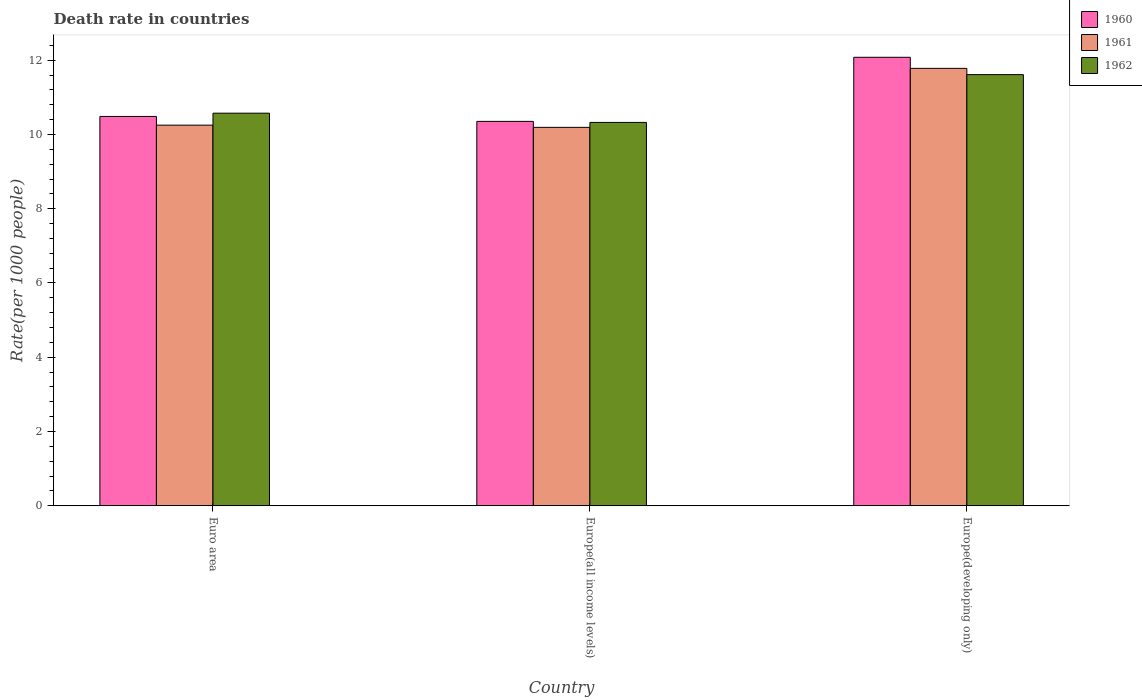How many different coloured bars are there?
Ensure brevity in your answer.  3. How many groups of bars are there?
Make the answer very short. 3. Are the number of bars per tick equal to the number of legend labels?
Your answer should be very brief. Yes. Are the number of bars on each tick of the X-axis equal?
Provide a short and direct response. Yes. How many bars are there on the 3rd tick from the left?
Keep it short and to the point. 3. What is the label of the 2nd group of bars from the left?
Ensure brevity in your answer.  Europe(all income levels). In how many cases, is the number of bars for a given country not equal to the number of legend labels?
Give a very brief answer. 0. What is the death rate in 1962 in Euro area?
Give a very brief answer. 10.57. Across all countries, what is the maximum death rate in 1960?
Ensure brevity in your answer.  12.08. Across all countries, what is the minimum death rate in 1960?
Give a very brief answer. 10.35. In which country was the death rate in 1962 maximum?
Give a very brief answer. Europe(developing only). In which country was the death rate in 1960 minimum?
Make the answer very short. Europe(all income levels). What is the total death rate in 1962 in the graph?
Keep it short and to the point. 32.51. What is the difference between the death rate in 1960 in Euro area and that in Europe(all income levels)?
Offer a very short reply. 0.13. What is the difference between the death rate in 1961 in Euro area and the death rate in 1960 in Europe(developing only)?
Your response must be concise. -1.83. What is the average death rate in 1960 per country?
Keep it short and to the point. 10.97. What is the difference between the death rate of/in 1962 and death rate of/in 1961 in Euro area?
Offer a very short reply. 0.32. In how many countries, is the death rate in 1961 greater than 0.8?
Offer a terse response. 3. What is the ratio of the death rate in 1962 in Euro area to that in Europe(all income levels)?
Give a very brief answer. 1.02. What is the difference between the highest and the second highest death rate in 1962?
Ensure brevity in your answer.  -0.25. What is the difference between the highest and the lowest death rate in 1960?
Provide a succinct answer. 1.73. Is it the case that in every country, the sum of the death rate in 1962 and death rate in 1961 is greater than the death rate in 1960?
Provide a short and direct response. Yes. Are all the bars in the graph horizontal?
Ensure brevity in your answer.  No. How many countries are there in the graph?
Ensure brevity in your answer.  3. Does the graph contain any zero values?
Keep it short and to the point. No. Does the graph contain grids?
Your response must be concise. No. How many legend labels are there?
Keep it short and to the point. 3. What is the title of the graph?
Give a very brief answer. Death rate in countries. Does "1995" appear as one of the legend labels in the graph?
Your answer should be compact. No. What is the label or title of the X-axis?
Your response must be concise. Country. What is the label or title of the Y-axis?
Keep it short and to the point. Rate(per 1000 people). What is the Rate(per 1000 people) of 1960 in Euro area?
Make the answer very short. 10.49. What is the Rate(per 1000 people) in 1961 in Euro area?
Provide a succinct answer. 10.25. What is the Rate(per 1000 people) of 1962 in Euro area?
Offer a terse response. 10.57. What is the Rate(per 1000 people) of 1960 in Europe(all income levels)?
Your response must be concise. 10.35. What is the Rate(per 1000 people) in 1961 in Europe(all income levels)?
Offer a very short reply. 10.19. What is the Rate(per 1000 people) in 1962 in Europe(all income levels)?
Offer a very short reply. 10.33. What is the Rate(per 1000 people) of 1960 in Europe(developing only)?
Your answer should be compact. 12.08. What is the Rate(per 1000 people) in 1961 in Europe(developing only)?
Your answer should be compact. 11.78. What is the Rate(per 1000 people) in 1962 in Europe(developing only)?
Provide a short and direct response. 11.61. Across all countries, what is the maximum Rate(per 1000 people) of 1960?
Ensure brevity in your answer.  12.08. Across all countries, what is the maximum Rate(per 1000 people) in 1961?
Provide a short and direct response. 11.78. Across all countries, what is the maximum Rate(per 1000 people) of 1962?
Provide a succinct answer. 11.61. Across all countries, what is the minimum Rate(per 1000 people) in 1960?
Your response must be concise. 10.35. Across all countries, what is the minimum Rate(per 1000 people) in 1961?
Keep it short and to the point. 10.19. Across all countries, what is the minimum Rate(per 1000 people) in 1962?
Provide a short and direct response. 10.33. What is the total Rate(per 1000 people) in 1960 in the graph?
Ensure brevity in your answer.  32.92. What is the total Rate(per 1000 people) of 1961 in the graph?
Give a very brief answer. 32.23. What is the total Rate(per 1000 people) in 1962 in the graph?
Your answer should be compact. 32.51. What is the difference between the Rate(per 1000 people) in 1960 in Euro area and that in Europe(all income levels)?
Provide a succinct answer. 0.13. What is the difference between the Rate(per 1000 people) of 1961 in Euro area and that in Europe(all income levels)?
Provide a succinct answer. 0.06. What is the difference between the Rate(per 1000 people) in 1962 in Euro area and that in Europe(all income levels)?
Your answer should be compact. 0.25. What is the difference between the Rate(per 1000 people) of 1960 in Euro area and that in Europe(developing only)?
Make the answer very short. -1.59. What is the difference between the Rate(per 1000 people) of 1961 in Euro area and that in Europe(developing only)?
Offer a very short reply. -1.53. What is the difference between the Rate(per 1000 people) in 1962 in Euro area and that in Europe(developing only)?
Give a very brief answer. -1.04. What is the difference between the Rate(per 1000 people) in 1960 in Europe(all income levels) and that in Europe(developing only)?
Your answer should be very brief. -1.73. What is the difference between the Rate(per 1000 people) in 1961 in Europe(all income levels) and that in Europe(developing only)?
Your answer should be very brief. -1.59. What is the difference between the Rate(per 1000 people) in 1962 in Europe(all income levels) and that in Europe(developing only)?
Offer a very short reply. -1.29. What is the difference between the Rate(per 1000 people) of 1960 in Euro area and the Rate(per 1000 people) of 1961 in Europe(all income levels)?
Provide a short and direct response. 0.29. What is the difference between the Rate(per 1000 people) in 1960 in Euro area and the Rate(per 1000 people) in 1962 in Europe(all income levels)?
Keep it short and to the point. 0.16. What is the difference between the Rate(per 1000 people) of 1961 in Euro area and the Rate(per 1000 people) of 1962 in Europe(all income levels)?
Ensure brevity in your answer.  -0.07. What is the difference between the Rate(per 1000 people) in 1960 in Euro area and the Rate(per 1000 people) in 1961 in Europe(developing only)?
Offer a very short reply. -1.3. What is the difference between the Rate(per 1000 people) of 1960 in Euro area and the Rate(per 1000 people) of 1962 in Europe(developing only)?
Keep it short and to the point. -1.13. What is the difference between the Rate(per 1000 people) of 1961 in Euro area and the Rate(per 1000 people) of 1962 in Europe(developing only)?
Keep it short and to the point. -1.36. What is the difference between the Rate(per 1000 people) of 1960 in Europe(all income levels) and the Rate(per 1000 people) of 1961 in Europe(developing only)?
Your answer should be very brief. -1.43. What is the difference between the Rate(per 1000 people) of 1960 in Europe(all income levels) and the Rate(per 1000 people) of 1962 in Europe(developing only)?
Your response must be concise. -1.26. What is the difference between the Rate(per 1000 people) of 1961 in Europe(all income levels) and the Rate(per 1000 people) of 1962 in Europe(developing only)?
Provide a succinct answer. -1.42. What is the average Rate(per 1000 people) in 1960 per country?
Provide a succinct answer. 10.97. What is the average Rate(per 1000 people) of 1961 per country?
Offer a very short reply. 10.74. What is the average Rate(per 1000 people) in 1962 per country?
Your answer should be compact. 10.84. What is the difference between the Rate(per 1000 people) in 1960 and Rate(per 1000 people) in 1961 in Euro area?
Offer a terse response. 0.23. What is the difference between the Rate(per 1000 people) in 1960 and Rate(per 1000 people) in 1962 in Euro area?
Offer a terse response. -0.09. What is the difference between the Rate(per 1000 people) of 1961 and Rate(per 1000 people) of 1962 in Euro area?
Make the answer very short. -0.32. What is the difference between the Rate(per 1000 people) of 1960 and Rate(per 1000 people) of 1961 in Europe(all income levels)?
Give a very brief answer. 0.16. What is the difference between the Rate(per 1000 people) of 1960 and Rate(per 1000 people) of 1962 in Europe(all income levels)?
Give a very brief answer. 0.03. What is the difference between the Rate(per 1000 people) of 1961 and Rate(per 1000 people) of 1962 in Europe(all income levels)?
Your answer should be compact. -0.13. What is the difference between the Rate(per 1000 people) of 1960 and Rate(per 1000 people) of 1961 in Europe(developing only)?
Your response must be concise. 0.3. What is the difference between the Rate(per 1000 people) of 1960 and Rate(per 1000 people) of 1962 in Europe(developing only)?
Keep it short and to the point. 0.47. What is the difference between the Rate(per 1000 people) of 1961 and Rate(per 1000 people) of 1962 in Europe(developing only)?
Provide a short and direct response. 0.17. What is the ratio of the Rate(per 1000 people) in 1960 in Euro area to that in Europe(all income levels)?
Give a very brief answer. 1.01. What is the ratio of the Rate(per 1000 people) in 1962 in Euro area to that in Europe(all income levels)?
Make the answer very short. 1.02. What is the ratio of the Rate(per 1000 people) of 1960 in Euro area to that in Europe(developing only)?
Make the answer very short. 0.87. What is the ratio of the Rate(per 1000 people) in 1961 in Euro area to that in Europe(developing only)?
Offer a terse response. 0.87. What is the ratio of the Rate(per 1000 people) of 1962 in Euro area to that in Europe(developing only)?
Provide a succinct answer. 0.91. What is the ratio of the Rate(per 1000 people) of 1960 in Europe(all income levels) to that in Europe(developing only)?
Offer a terse response. 0.86. What is the ratio of the Rate(per 1000 people) of 1961 in Europe(all income levels) to that in Europe(developing only)?
Provide a short and direct response. 0.87. What is the ratio of the Rate(per 1000 people) in 1962 in Europe(all income levels) to that in Europe(developing only)?
Give a very brief answer. 0.89. What is the difference between the highest and the second highest Rate(per 1000 people) of 1960?
Offer a terse response. 1.59. What is the difference between the highest and the second highest Rate(per 1000 people) in 1961?
Make the answer very short. 1.53. What is the difference between the highest and the second highest Rate(per 1000 people) of 1962?
Your response must be concise. 1.04. What is the difference between the highest and the lowest Rate(per 1000 people) in 1960?
Offer a very short reply. 1.73. What is the difference between the highest and the lowest Rate(per 1000 people) of 1961?
Provide a short and direct response. 1.59. What is the difference between the highest and the lowest Rate(per 1000 people) of 1962?
Provide a succinct answer. 1.29. 